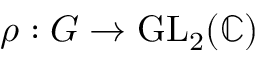<formula> <loc_0><loc_0><loc_500><loc_500>\rho \colon G \to { G L } _ { 2 } ( \mathbb { C } )</formula> 